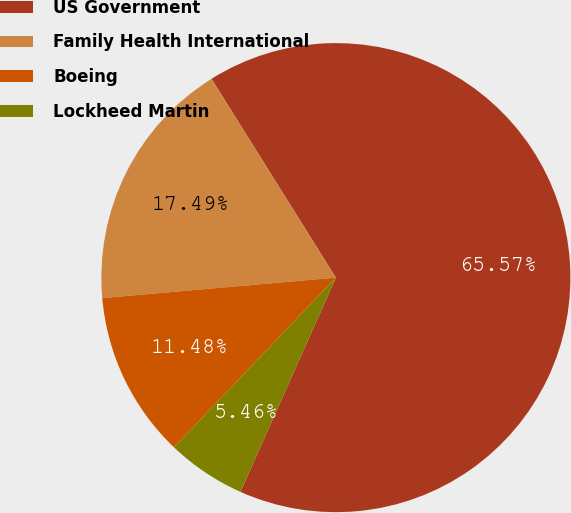Convert chart to OTSL. <chart><loc_0><loc_0><loc_500><loc_500><pie_chart><fcel>US Government<fcel>Family Health International<fcel>Boeing<fcel>Lockheed Martin<nl><fcel>65.57%<fcel>17.49%<fcel>11.48%<fcel>5.46%<nl></chart> 